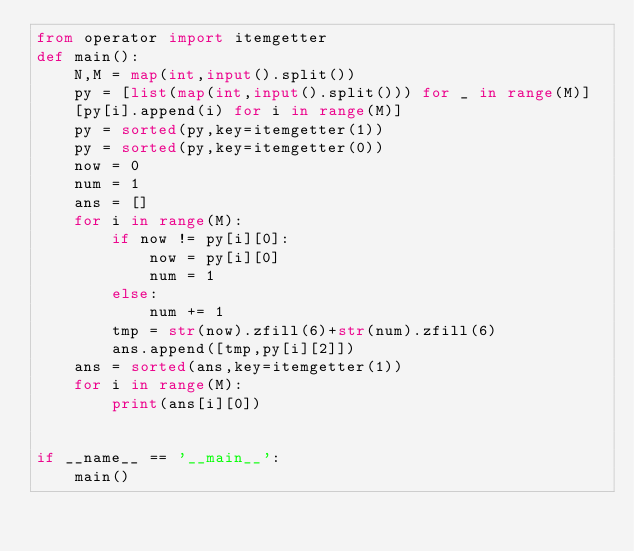Convert code to text. <code><loc_0><loc_0><loc_500><loc_500><_Python_>from operator import itemgetter
def main():
    N,M = map(int,input().split())
    py = [list(map(int,input().split())) for _ in range(M)]
    [py[i].append(i) for i in range(M)]
    py = sorted(py,key=itemgetter(1))
    py = sorted(py,key=itemgetter(0))
    now = 0
    num = 1
    ans = []
    for i in range(M):
        if now != py[i][0]:
            now = py[i][0]
            num = 1
        else:
            num += 1
        tmp = str(now).zfill(6)+str(num).zfill(6)
        ans.append([tmp,py[i][2]])
    ans = sorted(ans,key=itemgetter(1))
    for i in range(M):
        print(ans[i][0])


if __name__ == '__main__':
    main()</code> 